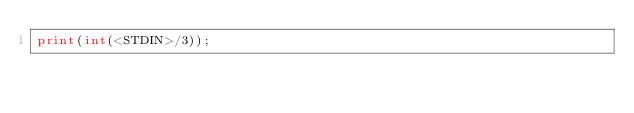Convert code to text. <code><loc_0><loc_0><loc_500><loc_500><_Perl_>print(int(<STDIN>/3));</code> 